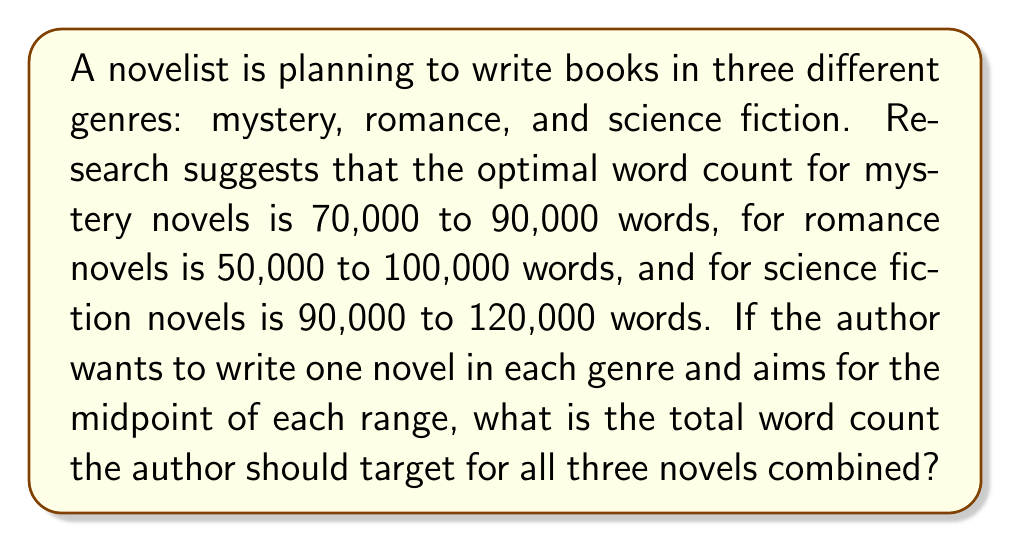What is the answer to this math problem? Let's approach this step-by-step:

1. Find the midpoint for each genre's word count range:

   Mystery: $\frac{70,000 + 90,000}{2} = 80,000$ words
   Romance: $\frac{50,000 + 100,000}{2} = 75,000$ words
   Science Fiction: $\frac{90,000 + 120,000}{2} = 105,000$ words

2. Sum up the midpoints for all three genres:

   $$\text{Total word count} = 80,000 + 75,000 + 105,000 = 260,000$$

Therefore, the author should aim for a total of 260,000 words for all three novels combined.
Answer: 260,000 words 